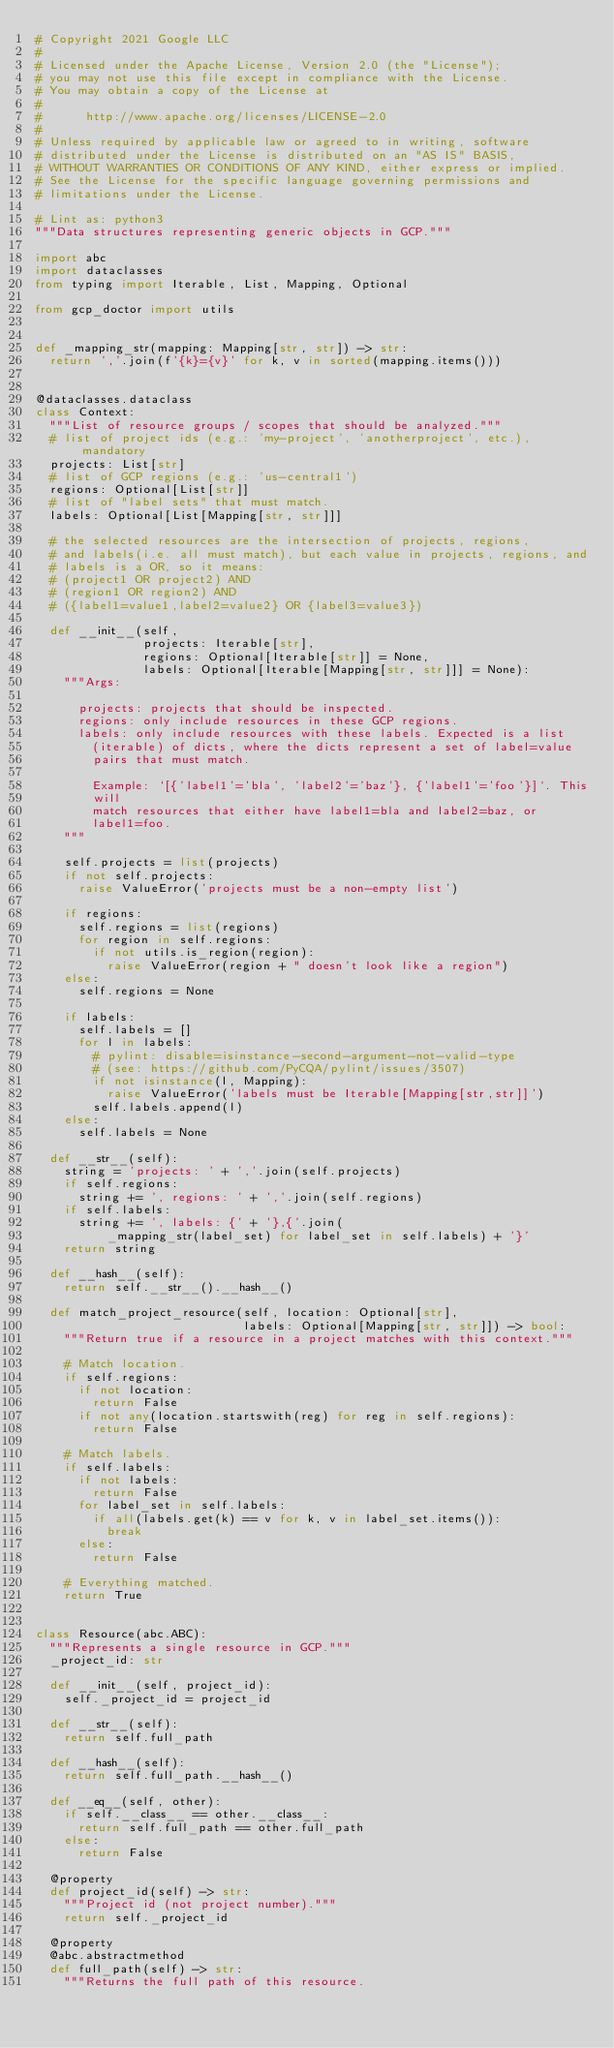<code> <loc_0><loc_0><loc_500><loc_500><_Python_># Copyright 2021 Google LLC
#
# Licensed under the Apache License, Version 2.0 (the "License");
# you may not use this file except in compliance with the License.
# You may obtain a copy of the License at
#
#      http://www.apache.org/licenses/LICENSE-2.0
#
# Unless required by applicable law or agreed to in writing, software
# distributed under the License is distributed on an "AS IS" BASIS,
# WITHOUT WARRANTIES OR CONDITIONS OF ANY KIND, either express or implied.
# See the License for the specific language governing permissions and
# limitations under the License.

# Lint as: python3
"""Data structures representing generic objects in GCP."""

import abc
import dataclasses
from typing import Iterable, List, Mapping, Optional

from gcp_doctor import utils


def _mapping_str(mapping: Mapping[str, str]) -> str:
  return ','.join(f'{k}={v}' for k, v in sorted(mapping.items()))


@dataclasses.dataclass
class Context:
  """List of resource groups / scopes that should be analyzed."""
  # list of project ids (e.g.: 'my-project', 'anotherproject', etc.), mandatory
  projects: List[str]
  # list of GCP regions (e.g.: 'us-central1')
  regions: Optional[List[str]]
  # list of "label sets" that must match.
  labels: Optional[List[Mapping[str, str]]]

  # the selected resources are the intersection of projects, regions,
  # and labels(i.e. all must match), but each value in projects, regions, and
  # labels is a OR, so it means:
  # (project1 OR project2) AND
  # (region1 OR region2) AND
  # ({label1=value1,label2=value2} OR {label3=value3})

  def __init__(self,
               projects: Iterable[str],
               regions: Optional[Iterable[str]] = None,
               labels: Optional[Iterable[Mapping[str, str]]] = None):
    """Args:

      projects: projects that should be inspected.
      regions: only include resources in these GCP regions.
      labels: only include resources with these labels. Expected is a list
        (iterable) of dicts, where the dicts represent a set of label=value
        pairs that must match.

        Example: `[{'label1'='bla', 'label2'='baz'}, {'label1'='foo'}]`. This
        will
        match resources that either have label1=bla and label2=baz, or
        label1=foo.
    """

    self.projects = list(projects)
    if not self.projects:
      raise ValueError('projects must be a non-empty list')

    if regions:
      self.regions = list(regions)
      for region in self.regions:
        if not utils.is_region(region):
          raise ValueError(region + " doesn't look like a region")
    else:
      self.regions = None

    if labels:
      self.labels = []
      for l in labels:
        # pylint: disable=isinstance-second-argument-not-valid-type
        # (see: https://github.com/PyCQA/pylint/issues/3507)
        if not isinstance(l, Mapping):
          raise ValueError('labels must be Iterable[Mapping[str,str]]')
        self.labels.append(l)
    else:
      self.labels = None

  def __str__(self):
    string = 'projects: ' + ','.join(self.projects)
    if self.regions:
      string += ', regions: ' + ','.join(self.regions)
    if self.labels:
      string += ', labels: {' + '},{'.join(
          _mapping_str(label_set) for label_set in self.labels) + '}'
    return string

  def __hash__(self):
    return self.__str__().__hash__()

  def match_project_resource(self, location: Optional[str],
                             labels: Optional[Mapping[str, str]]) -> bool:
    """Return true if a resource in a project matches with this context."""

    # Match location.
    if self.regions:
      if not location:
        return False
      if not any(location.startswith(reg) for reg in self.regions):
        return False

    # Match labels.
    if self.labels:
      if not labels:
        return False
      for label_set in self.labels:
        if all(labels.get(k) == v for k, v in label_set.items()):
          break
      else:
        return False

    # Everything matched.
    return True


class Resource(abc.ABC):
  """Represents a single resource in GCP."""
  _project_id: str

  def __init__(self, project_id):
    self._project_id = project_id

  def __str__(self):
    return self.full_path

  def __hash__(self):
    return self.full_path.__hash__()

  def __eq__(self, other):
    if self.__class__ == other.__class__:
      return self.full_path == other.full_path
    else:
      return False

  @property
  def project_id(self) -> str:
    """Project id (not project number)."""
    return self._project_id

  @property
  @abc.abstractmethod
  def full_path(self) -> str:
    """Returns the full path of this resource.
</code> 